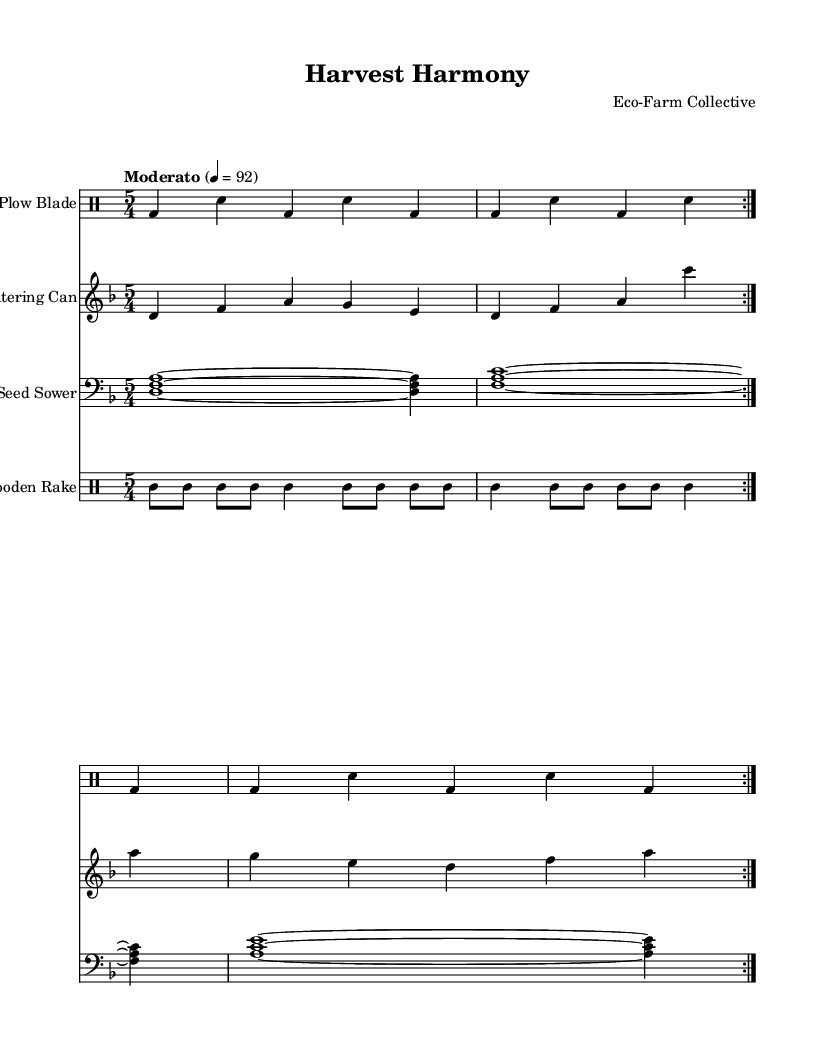What is the key signature of this music? The key signature is identified by the number of sharps or flats present at the beginning of the staff. In this case, the music is in D minor, which has one flat (B flat).
Answer: D minor What is the time signature of this music? The time signature is indicated by the numbers at the beginning of the piece. Here, it shows 5/4, meaning there are five beats per measure, and the quarter note gets one beat.
Answer: 5/4 What is the tempo marking of this music? The tempo marking is indicated at the beginning of the score. It is marked as Moderato, which typically indicates a moderate speed. The specific metronome marking given is 4 = 92.
Answer: Moderato How many times is the Rusty Plow Blade pattern repeated? To find the number of repetitions, we look at the repeat signs in the Rusty Plow Blade section, which indicate that the pattern is repeated twice.
Answer: 2 What instruments are used in this piece? The instruments are listed at the beginning of each staff. From the sheet music, we see the Rusty Plow Blade, Watering Can, Seed Sower, and Wooden Rake.
Answer: Rusty Plow Blade, Watering Can, Seed Sower, Wooden Rake What is the rhythmic pattern within the Watering Can section? Examining the notes in the Watering Can part shows a sequence of quarter notes in a repetitive melodic pattern across two measures, indicating a blend of rhythm and melody aiming to evoke a natural sound.
Answer: Quarter notes What texture best describes the music style of this piece? The texture can be understood by analyzing how many different instruments play simultaneously. In this score, multiple instruments are contributing layers of sound based on folk themes, leading to a rich, organic texture which is characteristic of experimental folk music.
Answer: Polyphonic 